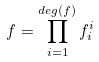<formula> <loc_0><loc_0><loc_500><loc_500>f = \prod _ { i = 1 } ^ { d e g ( f ) } f _ { i } ^ { i }</formula> 